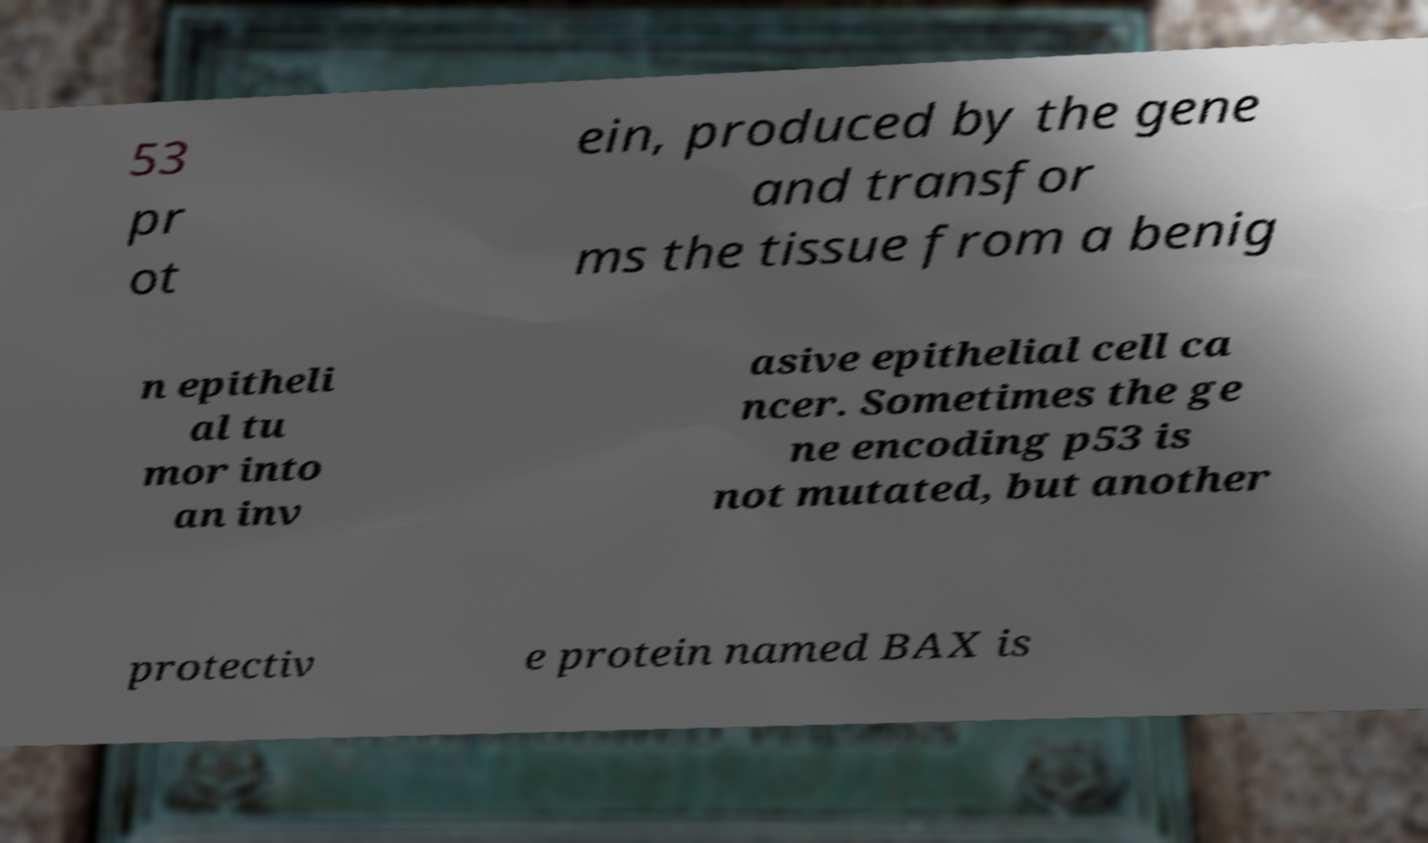I need the written content from this picture converted into text. Can you do that? 53 pr ot ein, produced by the gene and transfor ms the tissue from a benig n epitheli al tu mor into an inv asive epithelial cell ca ncer. Sometimes the ge ne encoding p53 is not mutated, but another protectiv e protein named BAX is 